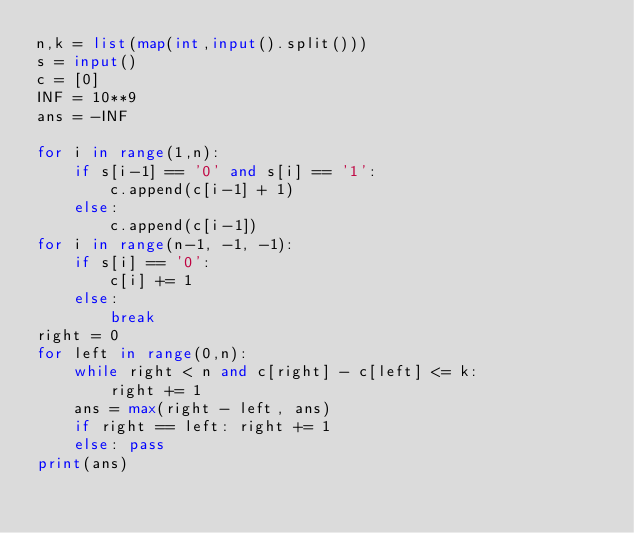<code> <loc_0><loc_0><loc_500><loc_500><_Python_>n,k = list(map(int,input().split()))
s = input()
c = [0]
INF = 10**9
ans = -INF

for i in range(1,n):
    if s[i-1] == '0' and s[i] == '1':
        c.append(c[i-1] + 1)
    else:
        c.append(c[i-1])
for i in range(n-1, -1, -1):
    if s[i] == '0':
        c[i] += 1
    else:
        break
right = 0
for left in range(0,n):
    while right < n and c[right] - c[left] <= k:
        right += 1
    ans = max(right - left, ans)
    if right == left: right += 1
    else: pass
print(ans)
</code> 